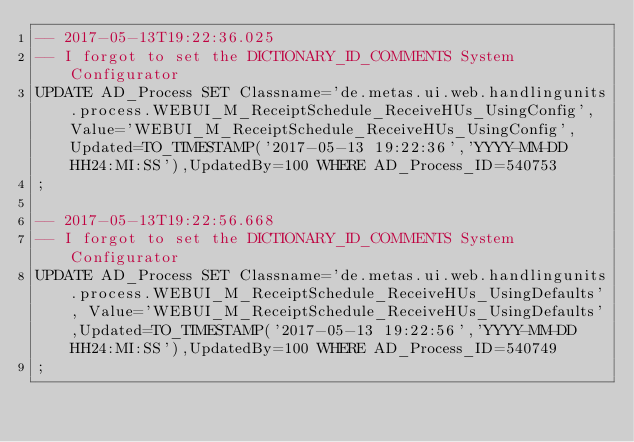Convert code to text. <code><loc_0><loc_0><loc_500><loc_500><_SQL_>-- 2017-05-13T19:22:36.025
-- I forgot to set the DICTIONARY_ID_COMMENTS System Configurator
UPDATE AD_Process SET Classname='de.metas.ui.web.handlingunits.process.WEBUI_M_ReceiptSchedule_ReceiveHUs_UsingConfig', Value='WEBUI_M_ReceiptSchedule_ReceiveHUs_UsingConfig',Updated=TO_TIMESTAMP('2017-05-13 19:22:36','YYYY-MM-DD HH24:MI:SS'),UpdatedBy=100 WHERE AD_Process_ID=540753
;

-- 2017-05-13T19:22:56.668
-- I forgot to set the DICTIONARY_ID_COMMENTS System Configurator
UPDATE AD_Process SET Classname='de.metas.ui.web.handlingunits.process.WEBUI_M_ReceiptSchedule_ReceiveHUs_UsingDefaults', Value='WEBUI_M_ReceiptSchedule_ReceiveHUs_UsingDefaults',Updated=TO_TIMESTAMP('2017-05-13 19:22:56','YYYY-MM-DD HH24:MI:SS'),UpdatedBy=100 WHERE AD_Process_ID=540749
;

</code> 